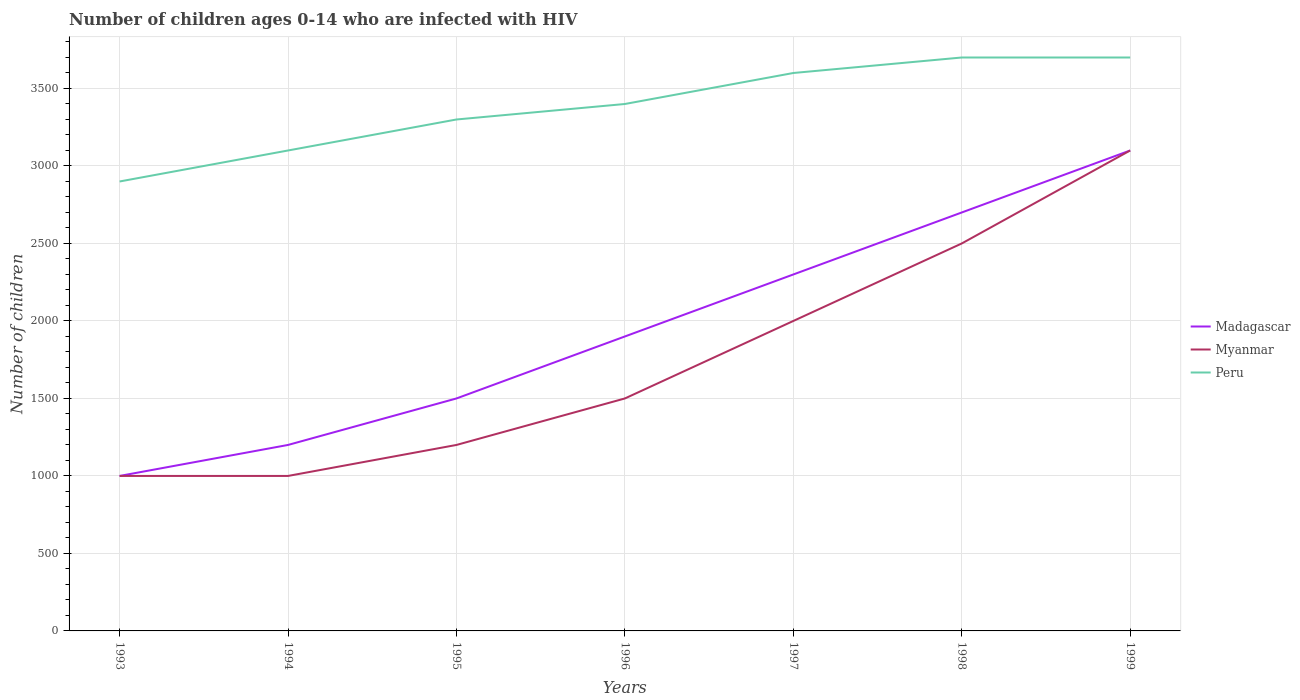Does the line corresponding to Peru intersect with the line corresponding to Madagascar?
Offer a very short reply. No. Across all years, what is the maximum number of HIV infected children in Peru?
Provide a succinct answer. 2900. In which year was the number of HIV infected children in Madagascar maximum?
Your response must be concise. 1993. What is the total number of HIV infected children in Peru in the graph?
Ensure brevity in your answer.  -400. What is the difference between the highest and the second highest number of HIV infected children in Peru?
Your answer should be compact. 800. What is the difference between the highest and the lowest number of HIV infected children in Myanmar?
Your answer should be very brief. 3. What is the difference between two consecutive major ticks on the Y-axis?
Your response must be concise. 500. Does the graph contain any zero values?
Give a very brief answer. No. Does the graph contain grids?
Provide a succinct answer. Yes. What is the title of the graph?
Ensure brevity in your answer.  Number of children ages 0-14 who are infected with HIV. Does "United Arab Emirates" appear as one of the legend labels in the graph?
Your response must be concise. No. What is the label or title of the X-axis?
Keep it short and to the point. Years. What is the label or title of the Y-axis?
Provide a succinct answer. Number of children. What is the Number of children of Madagascar in 1993?
Your answer should be compact. 1000. What is the Number of children of Peru in 1993?
Make the answer very short. 2900. What is the Number of children in Madagascar in 1994?
Provide a succinct answer. 1200. What is the Number of children of Myanmar in 1994?
Your answer should be compact. 1000. What is the Number of children of Peru in 1994?
Make the answer very short. 3100. What is the Number of children in Madagascar in 1995?
Your answer should be compact. 1500. What is the Number of children in Myanmar in 1995?
Make the answer very short. 1200. What is the Number of children of Peru in 1995?
Provide a short and direct response. 3300. What is the Number of children of Madagascar in 1996?
Ensure brevity in your answer.  1900. What is the Number of children of Myanmar in 1996?
Offer a terse response. 1500. What is the Number of children in Peru in 1996?
Your response must be concise. 3400. What is the Number of children of Madagascar in 1997?
Give a very brief answer. 2300. What is the Number of children in Peru in 1997?
Your response must be concise. 3600. What is the Number of children of Madagascar in 1998?
Provide a short and direct response. 2700. What is the Number of children of Myanmar in 1998?
Ensure brevity in your answer.  2500. What is the Number of children of Peru in 1998?
Offer a terse response. 3700. What is the Number of children in Madagascar in 1999?
Your response must be concise. 3100. What is the Number of children of Myanmar in 1999?
Offer a terse response. 3100. What is the Number of children in Peru in 1999?
Your answer should be compact. 3700. Across all years, what is the maximum Number of children in Madagascar?
Offer a terse response. 3100. Across all years, what is the maximum Number of children in Myanmar?
Your answer should be compact. 3100. Across all years, what is the maximum Number of children in Peru?
Offer a terse response. 3700. Across all years, what is the minimum Number of children in Madagascar?
Keep it short and to the point. 1000. Across all years, what is the minimum Number of children in Peru?
Your answer should be compact. 2900. What is the total Number of children in Madagascar in the graph?
Provide a short and direct response. 1.37e+04. What is the total Number of children of Myanmar in the graph?
Offer a very short reply. 1.23e+04. What is the total Number of children in Peru in the graph?
Your answer should be compact. 2.37e+04. What is the difference between the Number of children of Madagascar in 1993 and that in 1994?
Your answer should be very brief. -200. What is the difference between the Number of children in Peru in 1993 and that in 1994?
Ensure brevity in your answer.  -200. What is the difference between the Number of children of Madagascar in 1993 and that in 1995?
Ensure brevity in your answer.  -500. What is the difference between the Number of children of Myanmar in 1993 and that in 1995?
Offer a terse response. -200. What is the difference between the Number of children of Peru in 1993 and that in 1995?
Your answer should be compact. -400. What is the difference between the Number of children of Madagascar in 1993 and that in 1996?
Ensure brevity in your answer.  -900. What is the difference between the Number of children of Myanmar in 1993 and that in 1996?
Give a very brief answer. -500. What is the difference between the Number of children in Peru in 1993 and that in 1996?
Keep it short and to the point. -500. What is the difference between the Number of children of Madagascar in 1993 and that in 1997?
Give a very brief answer. -1300. What is the difference between the Number of children of Myanmar in 1993 and that in 1997?
Provide a short and direct response. -1000. What is the difference between the Number of children in Peru in 1993 and that in 1997?
Your answer should be compact. -700. What is the difference between the Number of children of Madagascar in 1993 and that in 1998?
Your answer should be compact. -1700. What is the difference between the Number of children in Myanmar in 1993 and that in 1998?
Offer a terse response. -1500. What is the difference between the Number of children of Peru in 1993 and that in 1998?
Make the answer very short. -800. What is the difference between the Number of children in Madagascar in 1993 and that in 1999?
Ensure brevity in your answer.  -2100. What is the difference between the Number of children of Myanmar in 1993 and that in 1999?
Offer a very short reply. -2100. What is the difference between the Number of children of Peru in 1993 and that in 1999?
Provide a short and direct response. -800. What is the difference between the Number of children of Madagascar in 1994 and that in 1995?
Provide a short and direct response. -300. What is the difference between the Number of children in Myanmar in 1994 and that in 1995?
Provide a succinct answer. -200. What is the difference between the Number of children of Peru in 1994 and that in 1995?
Keep it short and to the point. -200. What is the difference between the Number of children in Madagascar in 1994 and that in 1996?
Your answer should be very brief. -700. What is the difference between the Number of children of Myanmar in 1994 and that in 1996?
Make the answer very short. -500. What is the difference between the Number of children of Peru in 1994 and that in 1996?
Keep it short and to the point. -300. What is the difference between the Number of children of Madagascar in 1994 and that in 1997?
Provide a short and direct response. -1100. What is the difference between the Number of children in Myanmar in 1994 and that in 1997?
Provide a short and direct response. -1000. What is the difference between the Number of children of Peru in 1994 and that in 1997?
Your answer should be very brief. -500. What is the difference between the Number of children of Madagascar in 1994 and that in 1998?
Ensure brevity in your answer.  -1500. What is the difference between the Number of children in Myanmar in 1994 and that in 1998?
Keep it short and to the point. -1500. What is the difference between the Number of children in Peru in 1994 and that in 1998?
Your answer should be compact. -600. What is the difference between the Number of children in Madagascar in 1994 and that in 1999?
Provide a succinct answer. -1900. What is the difference between the Number of children of Myanmar in 1994 and that in 1999?
Make the answer very short. -2100. What is the difference between the Number of children in Peru in 1994 and that in 1999?
Your answer should be compact. -600. What is the difference between the Number of children in Madagascar in 1995 and that in 1996?
Provide a succinct answer. -400. What is the difference between the Number of children in Myanmar in 1995 and that in 1996?
Make the answer very short. -300. What is the difference between the Number of children of Peru in 1995 and that in 1996?
Offer a very short reply. -100. What is the difference between the Number of children of Madagascar in 1995 and that in 1997?
Provide a short and direct response. -800. What is the difference between the Number of children in Myanmar in 1995 and that in 1997?
Provide a succinct answer. -800. What is the difference between the Number of children of Peru in 1995 and that in 1997?
Offer a terse response. -300. What is the difference between the Number of children in Madagascar in 1995 and that in 1998?
Offer a very short reply. -1200. What is the difference between the Number of children of Myanmar in 1995 and that in 1998?
Provide a short and direct response. -1300. What is the difference between the Number of children of Peru in 1995 and that in 1998?
Your answer should be compact. -400. What is the difference between the Number of children in Madagascar in 1995 and that in 1999?
Offer a terse response. -1600. What is the difference between the Number of children of Myanmar in 1995 and that in 1999?
Your response must be concise. -1900. What is the difference between the Number of children in Peru in 1995 and that in 1999?
Ensure brevity in your answer.  -400. What is the difference between the Number of children in Madagascar in 1996 and that in 1997?
Offer a terse response. -400. What is the difference between the Number of children of Myanmar in 1996 and that in 1997?
Make the answer very short. -500. What is the difference between the Number of children in Peru in 1996 and that in 1997?
Offer a very short reply. -200. What is the difference between the Number of children of Madagascar in 1996 and that in 1998?
Your answer should be compact. -800. What is the difference between the Number of children in Myanmar in 1996 and that in 1998?
Ensure brevity in your answer.  -1000. What is the difference between the Number of children in Peru in 1996 and that in 1998?
Make the answer very short. -300. What is the difference between the Number of children of Madagascar in 1996 and that in 1999?
Offer a terse response. -1200. What is the difference between the Number of children in Myanmar in 1996 and that in 1999?
Offer a very short reply. -1600. What is the difference between the Number of children of Peru in 1996 and that in 1999?
Your answer should be compact. -300. What is the difference between the Number of children in Madagascar in 1997 and that in 1998?
Keep it short and to the point. -400. What is the difference between the Number of children in Myanmar in 1997 and that in 1998?
Keep it short and to the point. -500. What is the difference between the Number of children of Peru in 1997 and that in 1998?
Ensure brevity in your answer.  -100. What is the difference between the Number of children in Madagascar in 1997 and that in 1999?
Keep it short and to the point. -800. What is the difference between the Number of children of Myanmar in 1997 and that in 1999?
Provide a short and direct response. -1100. What is the difference between the Number of children of Peru in 1997 and that in 1999?
Provide a short and direct response. -100. What is the difference between the Number of children of Madagascar in 1998 and that in 1999?
Your response must be concise. -400. What is the difference between the Number of children in Myanmar in 1998 and that in 1999?
Ensure brevity in your answer.  -600. What is the difference between the Number of children in Peru in 1998 and that in 1999?
Your answer should be compact. 0. What is the difference between the Number of children of Madagascar in 1993 and the Number of children of Peru in 1994?
Provide a succinct answer. -2100. What is the difference between the Number of children in Myanmar in 1993 and the Number of children in Peru in 1994?
Your response must be concise. -2100. What is the difference between the Number of children in Madagascar in 1993 and the Number of children in Myanmar in 1995?
Give a very brief answer. -200. What is the difference between the Number of children of Madagascar in 1993 and the Number of children of Peru in 1995?
Your answer should be compact. -2300. What is the difference between the Number of children in Myanmar in 1993 and the Number of children in Peru in 1995?
Offer a terse response. -2300. What is the difference between the Number of children of Madagascar in 1993 and the Number of children of Myanmar in 1996?
Ensure brevity in your answer.  -500. What is the difference between the Number of children of Madagascar in 1993 and the Number of children of Peru in 1996?
Your response must be concise. -2400. What is the difference between the Number of children of Myanmar in 1993 and the Number of children of Peru in 1996?
Keep it short and to the point. -2400. What is the difference between the Number of children in Madagascar in 1993 and the Number of children in Myanmar in 1997?
Make the answer very short. -1000. What is the difference between the Number of children in Madagascar in 1993 and the Number of children in Peru in 1997?
Your answer should be very brief. -2600. What is the difference between the Number of children of Myanmar in 1993 and the Number of children of Peru in 1997?
Provide a short and direct response. -2600. What is the difference between the Number of children in Madagascar in 1993 and the Number of children in Myanmar in 1998?
Make the answer very short. -1500. What is the difference between the Number of children in Madagascar in 1993 and the Number of children in Peru in 1998?
Offer a very short reply. -2700. What is the difference between the Number of children of Myanmar in 1993 and the Number of children of Peru in 1998?
Provide a short and direct response. -2700. What is the difference between the Number of children in Madagascar in 1993 and the Number of children in Myanmar in 1999?
Make the answer very short. -2100. What is the difference between the Number of children in Madagascar in 1993 and the Number of children in Peru in 1999?
Make the answer very short. -2700. What is the difference between the Number of children of Myanmar in 1993 and the Number of children of Peru in 1999?
Make the answer very short. -2700. What is the difference between the Number of children in Madagascar in 1994 and the Number of children in Peru in 1995?
Make the answer very short. -2100. What is the difference between the Number of children in Myanmar in 1994 and the Number of children in Peru in 1995?
Your answer should be very brief. -2300. What is the difference between the Number of children of Madagascar in 1994 and the Number of children of Myanmar in 1996?
Your response must be concise. -300. What is the difference between the Number of children of Madagascar in 1994 and the Number of children of Peru in 1996?
Offer a terse response. -2200. What is the difference between the Number of children of Myanmar in 1994 and the Number of children of Peru in 1996?
Offer a very short reply. -2400. What is the difference between the Number of children of Madagascar in 1994 and the Number of children of Myanmar in 1997?
Offer a terse response. -800. What is the difference between the Number of children of Madagascar in 1994 and the Number of children of Peru in 1997?
Give a very brief answer. -2400. What is the difference between the Number of children of Myanmar in 1994 and the Number of children of Peru in 1997?
Offer a very short reply. -2600. What is the difference between the Number of children in Madagascar in 1994 and the Number of children in Myanmar in 1998?
Provide a short and direct response. -1300. What is the difference between the Number of children in Madagascar in 1994 and the Number of children in Peru in 1998?
Your answer should be compact. -2500. What is the difference between the Number of children in Myanmar in 1994 and the Number of children in Peru in 1998?
Ensure brevity in your answer.  -2700. What is the difference between the Number of children of Madagascar in 1994 and the Number of children of Myanmar in 1999?
Give a very brief answer. -1900. What is the difference between the Number of children in Madagascar in 1994 and the Number of children in Peru in 1999?
Provide a short and direct response. -2500. What is the difference between the Number of children in Myanmar in 1994 and the Number of children in Peru in 1999?
Offer a very short reply. -2700. What is the difference between the Number of children in Madagascar in 1995 and the Number of children in Peru in 1996?
Provide a short and direct response. -1900. What is the difference between the Number of children in Myanmar in 1995 and the Number of children in Peru in 1996?
Give a very brief answer. -2200. What is the difference between the Number of children in Madagascar in 1995 and the Number of children in Myanmar in 1997?
Make the answer very short. -500. What is the difference between the Number of children in Madagascar in 1995 and the Number of children in Peru in 1997?
Your answer should be very brief. -2100. What is the difference between the Number of children of Myanmar in 1995 and the Number of children of Peru in 1997?
Ensure brevity in your answer.  -2400. What is the difference between the Number of children of Madagascar in 1995 and the Number of children of Myanmar in 1998?
Your answer should be very brief. -1000. What is the difference between the Number of children of Madagascar in 1995 and the Number of children of Peru in 1998?
Provide a succinct answer. -2200. What is the difference between the Number of children of Myanmar in 1995 and the Number of children of Peru in 1998?
Provide a succinct answer. -2500. What is the difference between the Number of children of Madagascar in 1995 and the Number of children of Myanmar in 1999?
Provide a short and direct response. -1600. What is the difference between the Number of children of Madagascar in 1995 and the Number of children of Peru in 1999?
Keep it short and to the point. -2200. What is the difference between the Number of children in Myanmar in 1995 and the Number of children in Peru in 1999?
Ensure brevity in your answer.  -2500. What is the difference between the Number of children in Madagascar in 1996 and the Number of children in Myanmar in 1997?
Your answer should be very brief. -100. What is the difference between the Number of children of Madagascar in 1996 and the Number of children of Peru in 1997?
Offer a very short reply. -1700. What is the difference between the Number of children of Myanmar in 1996 and the Number of children of Peru in 1997?
Offer a terse response. -2100. What is the difference between the Number of children in Madagascar in 1996 and the Number of children in Myanmar in 1998?
Your response must be concise. -600. What is the difference between the Number of children in Madagascar in 1996 and the Number of children in Peru in 1998?
Ensure brevity in your answer.  -1800. What is the difference between the Number of children in Myanmar in 1996 and the Number of children in Peru in 1998?
Provide a short and direct response. -2200. What is the difference between the Number of children in Madagascar in 1996 and the Number of children in Myanmar in 1999?
Keep it short and to the point. -1200. What is the difference between the Number of children of Madagascar in 1996 and the Number of children of Peru in 1999?
Provide a succinct answer. -1800. What is the difference between the Number of children in Myanmar in 1996 and the Number of children in Peru in 1999?
Your answer should be compact. -2200. What is the difference between the Number of children of Madagascar in 1997 and the Number of children of Myanmar in 1998?
Your answer should be compact. -200. What is the difference between the Number of children in Madagascar in 1997 and the Number of children in Peru in 1998?
Your answer should be very brief. -1400. What is the difference between the Number of children of Myanmar in 1997 and the Number of children of Peru in 1998?
Ensure brevity in your answer.  -1700. What is the difference between the Number of children of Madagascar in 1997 and the Number of children of Myanmar in 1999?
Keep it short and to the point. -800. What is the difference between the Number of children of Madagascar in 1997 and the Number of children of Peru in 1999?
Keep it short and to the point. -1400. What is the difference between the Number of children of Myanmar in 1997 and the Number of children of Peru in 1999?
Your answer should be compact. -1700. What is the difference between the Number of children in Madagascar in 1998 and the Number of children in Myanmar in 1999?
Offer a terse response. -400. What is the difference between the Number of children of Madagascar in 1998 and the Number of children of Peru in 1999?
Provide a short and direct response. -1000. What is the difference between the Number of children of Myanmar in 1998 and the Number of children of Peru in 1999?
Make the answer very short. -1200. What is the average Number of children of Madagascar per year?
Your response must be concise. 1957.14. What is the average Number of children in Myanmar per year?
Offer a very short reply. 1757.14. What is the average Number of children in Peru per year?
Offer a terse response. 3385.71. In the year 1993, what is the difference between the Number of children of Madagascar and Number of children of Peru?
Offer a terse response. -1900. In the year 1993, what is the difference between the Number of children of Myanmar and Number of children of Peru?
Ensure brevity in your answer.  -1900. In the year 1994, what is the difference between the Number of children of Madagascar and Number of children of Myanmar?
Offer a very short reply. 200. In the year 1994, what is the difference between the Number of children in Madagascar and Number of children in Peru?
Provide a succinct answer. -1900. In the year 1994, what is the difference between the Number of children in Myanmar and Number of children in Peru?
Your answer should be compact. -2100. In the year 1995, what is the difference between the Number of children of Madagascar and Number of children of Myanmar?
Keep it short and to the point. 300. In the year 1995, what is the difference between the Number of children of Madagascar and Number of children of Peru?
Give a very brief answer. -1800. In the year 1995, what is the difference between the Number of children of Myanmar and Number of children of Peru?
Ensure brevity in your answer.  -2100. In the year 1996, what is the difference between the Number of children of Madagascar and Number of children of Myanmar?
Your response must be concise. 400. In the year 1996, what is the difference between the Number of children in Madagascar and Number of children in Peru?
Provide a short and direct response. -1500. In the year 1996, what is the difference between the Number of children of Myanmar and Number of children of Peru?
Give a very brief answer. -1900. In the year 1997, what is the difference between the Number of children of Madagascar and Number of children of Myanmar?
Provide a succinct answer. 300. In the year 1997, what is the difference between the Number of children in Madagascar and Number of children in Peru?
Give a very brief answer. -1300. In the year 1997, what is the difference between the Number of children in Myanmar and Number of children in Peru?
Your response must be concise. -1600. In the year 1998, what is the difference between the Number of children of Madagascar and Number of children of Peru?
Your answer should be very brief. -1000. In the year 1998, what is the difference between the Number of children of Myanmar and Number of children of Peru?
Keep it short and to the point. -1200. In the year 1999, what is the difference between the Number of children in Madagascar and Number of children in Myanmar?
Make the answer very short. 0. In the year 1999, what is the difference between the Number of children of Madagascar and Number of children of Peru?
Make the answer very short. -600. In the year 1999, what is the difference between the Number of children of Myanmar and Number of children of Peru?
Your response must be concise. -600. What is the ratio of the Number of children of Madagascar in 1993 to that in 1994?
Ensure brevity in your answer.  0.83. What is the ratio of the Number of children of Myanmar in 1993 to that in 1994?
Provide a short and direct response. 1. What is the ratio of the Number of children of Peru in 1993 to that in 1994?
Offer a terse response. 0.94. What is the ratio of the Number of children in Myanmar in 1993 to that in 1995?
Provide a succinct answer. 0.83. What is the ratio of the Number of children in Peru in 1993 to that in 1995?
Provide a succinct answer. 0.88. What is the ratio of the Number of children in Madagascar in 1993 to that in 1996?
Provide a short and direct response. 0.53. What is the ratio of the Number of children in Peru in 1993 to that in 1996?
Offer a very short reply. 0.85. What is the ratio of the Number of children of Madagascar in 1993 to that in 1997?
Provide a short and direct response. 0.43. What is the ratio of the Number of children in Peru in 1993 to that in 1997?
Keep it short and to the point. 0.81. What is the ratio of the Number of children in Madagascar in 1993 to that in 1998?
Your answer should be compact. 0.37. What is the ratio of the Number of children in Myanmar in 1993 to that in 1998?
Your answer should be very brief. 0.4. What is the ratio of the Number of children of Peru in 1993 to that in 1998?
Make the answer very short. 0.78. What is the ratio of the Number of children of Madagascar in 1993 to that in 1999?
Ensure brevity in your answer.  0.32. What is the ratio of the Number of children in Myanmar in 1993 to that in 1999?
Make the answer very short. 0.32. What is the ratio of the Number of children in Peru in 1993 to that in 1999?
Make the answer very short. 0.78. What is the ratio of the Number of children of Madagascar in 1994 to that in 1995?
Make the answer very short. 0.8. What is the ratio of the Number of children of Myanmar in 1994 to that in 1995?
Ensure brevity in your answer.  0.83. What is the ratio of the Number of children in Peru in 1994 to that in 1995?
Offer a terse response. 0.94. What is the ratio of the Number of children in Madagascar in 1994 to that in 1996?
Provide a short and direct response. 0.63. What is the ratio of the Number of children of Peru in 1994 to that in 1996?
Your answer should be very brief. 0.91. What is the ratio of the Number of children in Madagascar in 1994 to that in 1997?
Make the answer very short. 0.52. What is the ratio of the Number of children in Myanmar in 1994 to that in 1997?
Ensure brevity in your answer.  0.5. What is the ratio of the Number of children of Peru in 1994 to that in 1997?
Ensure brevity in your answer.  0.86. What is the ratio of the Number of children in Madagascar in 1994 to that in 1998?
Provide a short and direct response. 0.44. What is the ratio of the Number of children of Peru in 1994 to that in 1998?
Offer a very short reply. 0.84. What is the ratio of the Number of children in Madagascar in 1994 to that in 1999?
Provide a short and direct response. 0.39. What is the ratio of the Number of children in Myanmar in 1994 to that in 1999?
Provide a succinct answer. 0.32. What is the ratio of the Number of children in Peru in 1994 to that in 1999?
Offer a terse response. 0.84. What is the ratio of the Number of children in Madagascar in 1995 to that in 1996?
Your answer should be very brief. 0.79. What is the ratio of the Number of children of Peru in 1995 to that in 1996?
Offer a terse response. 0.97. What is the ratio of the Number of children in Madagascar in 1995 to that in 1997?
Offer a very short reply. 0.65. What is the ratio of the Number of children in Myanmar in 1995 to that in 1997?
Offer a terse response. 0.6. What is the ratio of the Number of children of Peru in 1995 to that in 1997?
Offer a very short reply. 0.92. What is the ratio of the Number of children of Madagascar in 1995 to that in 1998?
Offer a terse response. 0.56. What is the ratio of the Number of children of Myanmar in 1995 to that in 1998?
Give a very brief answer. 0.48. What is the ratio of the Number of children of Peru in 1995 to that in 1998?
Provide a short and direct response. 0.89. What is the ratio of the Number of children of Madagascar in 1995 to that in 1999?
Your answer should be very brief. 0.48. What is the ratio of the Number of children in Myanmar in 1995 to that in 1999?
Ensure brevity in your answer.  0.39. What is the ratio of the Number of children in Peru in 1995 to that in 1999?
Give a very brief answer. 0.89. What is the ratio of the Number of children of Madagascar in 1996 to that in 1997?
Your answer should be very brief. 0.83. What is the ratio of the Number of children in Myanmar in 1996 to that in 1997?
Ensure brevity in your answer.  0.75. What is the ratio of the Number of children in Madagascar in 1996 to that in 1998?
Offer a terse response. 0.7. What is the ratio of the Number of children in Myanmar in 1996 to that in 1998?
Make the answer very short. 0.6. What is the ratio of the Number of children in Peru in 1996 to that in 1998?
Offer a very short reply. 0.92. What is the ratio of the Number of children in Madagascar in 1996 to that in 1999?
Offer a very short reply. 0.61. What is the ratio of the Number of children of Myanmar in 1996 to that in 1999?
Your answer should be very brief. 0.48. What is the ratio of the Number of children of Peru in 1996 to that in 1999?
Provide a short and direct response. 0.92. What is the ratio of the Number of children of Madagascar in 1997 to that in 1998?
Make the answer very short. 0.85. What is the ratio of the Number of children in Myanmar in 1997 to that in 1998?
Provide a succinct answer. 0.8. What is the ratio of the Number of children in Madagascar in 1997 to that in 1999?
Ensure brevity in your answer.  0.74. What is the ratio of the Number of children of Myanmar in 1997 to that in 1999?
Your response must be concise. 0.65. What is the ratio of the Number of children in Peru in 1997 to that in 1999?
Give a very brief answer. 0.97. What is the ratio of the Number of children of Madagascar in 1998 to that in 1999?
Your answer should be very brief. 0.87. What is the ratio of the Number of children in Myanmar in 1998 to that in 1999?
Your answer should be compact. 0.81. What is the ratio of the Number of children in Peru in 1998 to that in 1999?
Make the answer very short. 1. What is the difference between the highest and the second highest Number of children in Myanmar?
Give a very brief answer. 600. What is the difference between the highest and the lowest Number of children of Madagascar?
Your response must be concise. 2100. What is the difference between the highest and the lowest Number of children in Myanmar?
Provide a succinct answer. 2100. What is the difference between the highest and the lowest Number of children of Peru?
Keep it short and to the point. 800. 